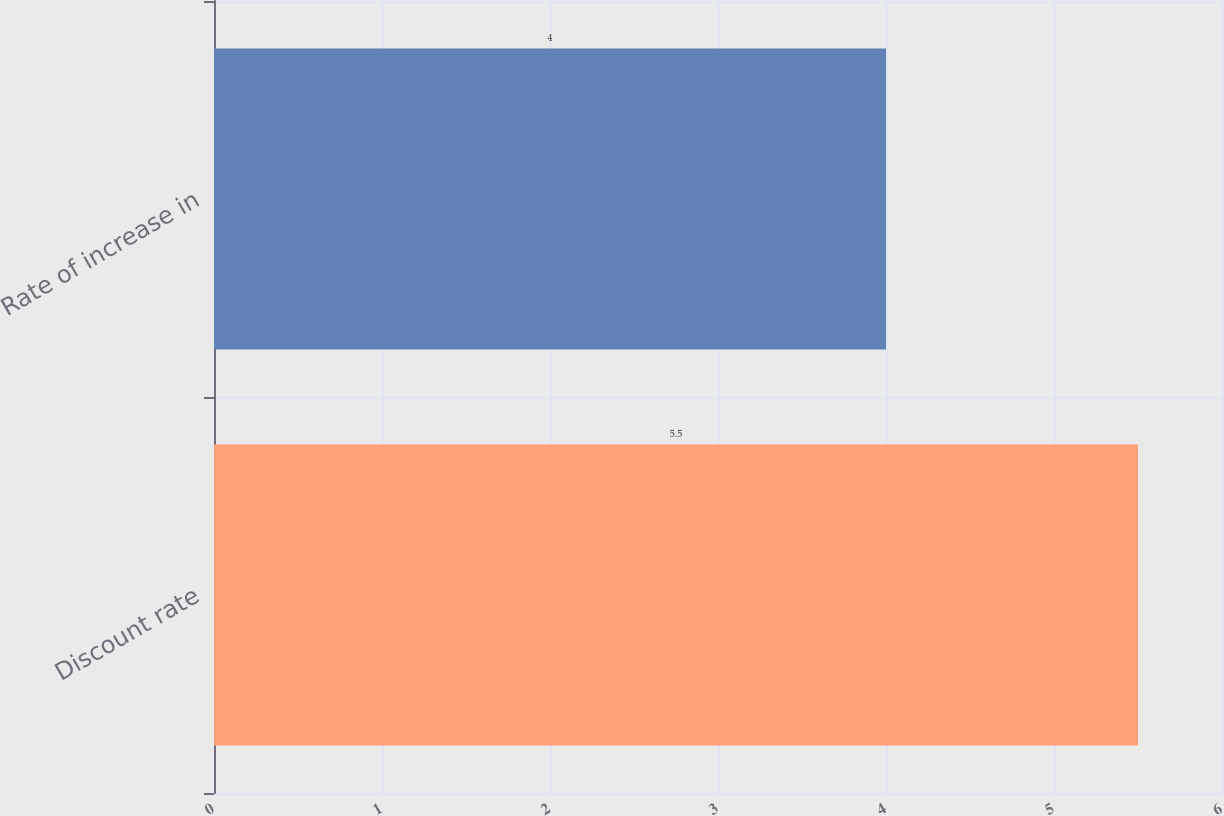Convert chart to OTSL. <chart><loc_0><loc_0><loc_500><loc_500><bar_chart><fcel>Discount rate<fcel>Rate of increase in<nl><fcel>5.5<fcel>4<nl></chart> 